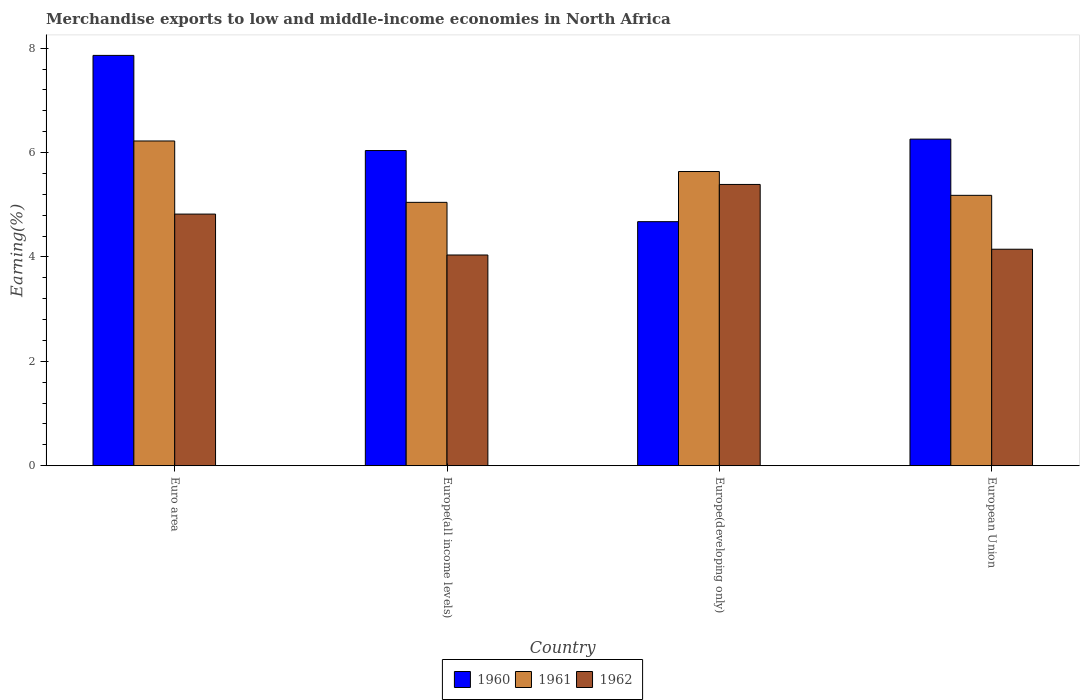How many different coloured bars are there?
Give a very brief answer. 3. How many groups of bars are there?
Give a very brief answer. 4. How many bars are there on the 2nd tick from the left?
Your response must be concise. 3. How many bars are there on the 4th tick from the right?
Your answer should be very brief. 3. What is the label of the 1st group of bars from the left?
Your answer should be compact. Euro area. In how many cases, is the number of bars for a given country not equal to the number of legend labels?
Ensure brevity in your answer.  0. What is the percentage of amount earned from merchandise exports in 1961 in Euro area?
Your response must be concise. 6.22. Across all countries, what is the maximum percentage of amount earned from merchandise exports in 1962?
Ensure brevity in your answer.  5.39. Across all countries, what is the minimum percentage of amount earned from merchandise exports in 1962?
Provide a succinct answer. 4.04. In which country was the percentage of amount earned from merchandise exports in 1960 maximum?
Provide a succinct answer. Euro area. In which country was the percentage of amount earned from merchandise exports in 1960 minimum?
Provide a succinct answer. Europe(developing only). What is the total percentage of amount earned from merchandise exports in 1962 in the graph?
Provide a succinct answer. 18.4. What is the difference between the percentage of amount earned from merchandise exports in 1960 in Euro area and that in Europe(all income levels)?
Offer a terse response. 1.82. What is the difference between the percentage of amount earned from merchandise exports in 1960 in Europe(developing only) and the percentage of amount earned from merchandise exports in 1962 in Europe(all income levels)?
Keep it short and to the point. 0.64. What is the average percentage of amount earned from merchandise exports in 1960 per country?
Provide a short and direct response. 6.21. What is the difference between the percentage of amount earned from merchandise exports of/in 1962 and percentage of amount earned from merchandise exports of/in 1960 in Europe(developing only)?
Ensure brevity in your answer.  0.71. In how many countries, is the percentage of amount earned from merchandise exports in 1961 greater than 4.4 %?
Offer a terse response. 4. What is the ratio of the percentage of amount earned from merchandise exports in 1960 in Euro area to that in European Union?
Your answer should be very brief. 1.26. Is the percentage of amount earned from merchandise exports in 1960 in Europe(developing only) less than that in European Union?
Provide a succinct answer. Yes. What is the difference between the highest and the second highest percentage of amount earned from merchandise exports in 1961?
Make the answer very short. -0.46. What is the difference between the highest and the lowest percentage of amount earned from merchandise exports in 1962?
Your answer should be very brief. 1.35. Is the sum of the percentage of amount earned from merchandise exports in 1961 in Europe(all income levels) and Europe(developing only) greater than the maximum percentage of amount earned from merchandise exports in 1960 across all countries?
Ensure brevity in your answer.  Yes. What does the 3rd bar from the left in European Union represents?
Keep it short and to the point. 1962. What does the 3rd bar from the right in Europe(all income levels) represents?
Offer a very short reply. 1960. Is it the case that in every country, the sum of the percentage of amount earned from merchandise exports in 1961 and percentage of amount earned from merchandise exports in 1962 is greater than the percentage of amount earned from merchandise exports in 1960?
Offer a terse response. Yes. Are all the bars in the graph horizontal?
Your response must be concise. No. How many countries are there in the graph?
Provide a short and direct response. 4. Are the values on the major ticks of Y-axis written in scientific E-notation?
Your answer should be compact. No. Does the graph contain any zero values?
Your response must be concise. No. How are the legend labels stacked?
Your answer should be compact. Horizontal. What is the title of the graph?
Your response must be concise. Merchandise exports to low and middle-income economies in North Africa. Does "1969" appear as one of the legend labels in the graph?
Give a very brief answer. No. What is the label or title of the Y-axis?
Offer a very short reply. Earning(%). What is the Earning(%) in 1960 in Euro area?
Provide a short and direct response. 7.86. What is the Earning(%) of 1961 in Euro area?
Provide a short and direct response. 6.22. What is the Earning(%) in 1962 in Euro area?
Your answer should be very brief. 4.82. What is the Earning(%) of 1960 in Europe(all income levels)?
Provide a short and direct response. 6.04. What is the Earning(%) of 1961 in Europe(all income levels)?
Your answer should be very brief. 5.05. What is the Earning(%) in 1962 in Europe(all income levels)?
Offer a terse response. 4.04. What is the Earning(%) in 1960 in Europe(developing only)?
Your answer should be compact. 4.68. What is the Earning(%) in 1961 in Europe(developing only)?
Offer a terse response. 5.64. What is the Earning(%) in 1962 in Europe(developing only)?
Make the answer very short. 5.39. What is the Earning(%) of 1960 in European Union?
Give a very brief answer. 6.26. What is the Earning(%) of 1961 in European Union?
Keep it short and to the point. 5.18. What is the Earning(%) of 1962 in European Union?
Keep it short and to the point. 4.15. Across all countries, what is the maximum Earning(%) in 1960?
Make the answer very short. 7.86. Across all countries, what is the maximum Earning(%) of 1961?
Provide a succinct answer. 6.22. Across all countries, what is the maximum Earning(%) in 1962?
Keep it short and to the point. 5.39. Across all countries, what is the minimum Earning(%) of 1960?
Your response must be concise. 4.68. Across all countries, what is the minimum Earning(%) of 1961?
Provide a short and direct response. 5.05. Across all countries, what is the minimum Earning(%) in 1962?
Keep it short and to the point. 4.04. What is the total Earning(%) in 1960 in the graph?
Keep it short and to the point. 24.84. What is the total Earning(%) in 1961 in the graph?
Provide a succinct answer. 22.09. What is the total Earning(%) of 1962 in the graph?
Your response must be concise. 18.4. What is the difference between the Earning(%) in 1960 in Euro area and that in Europe(all income levels)?
Offer a very short reply. 1.82. What is the difference between the Earning(%) of 1961 in Euro area and that in Europe(all income levels)?
Provide a succinct answer. 1.18. What is the difference between the Earning(%) in 1962 in Euro area and that in Europe(all income levels)?
Keep it short and to the point. 0.78. What is the difference between the Earning(%) of 1960 in Euro area and that in Europe(developing only)?
Your response must be concise. 3.19. What is the difference between the Earning(%) of 1961 in Euro area and that in Europe(developing only)?
Offer a terse response. 0.59. What is the difference between the Earning(%) in 1962 in Euro area and that in Europe(developing only)?
Ensure brevity in your answer.  -0.57. What is the difference between the Earning(%) in 1960 in Euro area and that in European Union?
Offer a terse response. 1.6. What is the difference between the Earning(%) in 1961 in Euro area and that in European Union?
Make the answer very short. 1.04. What is the difference between the Earning(%) in 1962 in Euro area and that in European Union?
Make the answer very short. 0.67. What is the difference between the Earning(%) of 1960 in Europe(all income levels) and that in Europe(developing only)?
Your response must be concise. 1.36. What is the difference between the Earning(%) in 1961 in Europe(all income levels) and that in Europe(developing only)?
Your response must be concise. -0.59. What is the difference between the Earning(%) of 1962 in Europe(all income levels) and that in Europe(developing only)?
Offer a terse response. -1.35. What is the difference between the Earning(%) in 1960 in Europe(all income levels) and that in European Union?
Make the answer very short. -0.22. What is the difference between the Earning(%) of 1961 in Europe(all income levels) and that in European Union?
Give a very brief answer. -0.13. What is the difference between the Earning(%) in 1962 in Europe(all income levels) and that in European Union?
Keep it short and to the point. -0.11. What is the difference between the Earning(%) in 1960 in Europe(developing only) and that in European Union?
Make the answer very short. -1.58. What is the difference between the Earning(%) in 1961 in Europe(developing only) and that in European Union?
Keep it short and to the point. 0.46. What is the difference between the Earning(%) of 1962 in Europe(developing only) and that in European Union?
Provide a succinct answer. 1.24. What is the difference between the Earning(%) in 1960 in Euro area and the Earning(%) in 1961 in Europe(all income levels)?
Provide a succinct answer. 2.82. What is the difference between the Earning(%) of 1960 in Euro area and the Earning(%) of 1962 in Europe(all income levels)?
Make the answer very short. 3.82. What is the difference between the Earning(%) in 1961 in Euro area and the Earning(%) in 1962 in Europe(all income levels)?
Ensure brevity in your answer.  2.18. What is the difference between the Earning(%) of 1960 in Euro area and the Earning(%) of 1961 in Europe(developing only)?
Offer a terse response. 2.23. What is the difference between the Earning(%) in 1960 in Euro area and the Earning(%) in 1962 in Europe(developing only)?
Your answer should be compact. 2.47. What is the difference between the Earning(%) in 1961 in Euro area and the Earning(%) in 1962 in Europe(developing only)?
Offer a very short reply. 0.83. What is the difference between the Earning(%) in 1960 in Euro area and the Earning(%) in 1961 in European Union?
Offer a very short reply. 2.68. What is the difference between the Earning(%) in 1960 in Euro area and the Earning(%) in 1962 in European Union?
Your response must be concise. 3.71. What is the difference between the Earning(%) in 1961 in Euro area and the Earning(%) in 1962 in European Union?
Provide a succinct answer. 2.07. What is the difference between the Earning(%) in 1960 in Europe(all income levels) and the Earning(%) in 1961 in Europe(developing only)?
Offer a very short reply. 0.4. What is the difference between the Earning(%) in 1960 in Europe(all income levels) and the Earning(%) in 1962 in Europe(developing only)?
Offer a very short reply. 0.65. What is the difference between the Earning(%) of 1961 in Europe(all income levels) and the Earning(%) of 1962 in Europe(developing only)?
Give a very brief answer. -0.34. What is the difference between the Earning(%) of 1960 in Europe(all income levels) and the Earning(%) of 1961 in European Union?
Ensure brevity in your answer.  0.86. What is the difference between the Earning(%) in 1960 in Europe(all income levels) and the Earning(%) in 1962 in European Union?
Offer a very short reply. 1.89. What is the difference between the Earning(%) of 1961 in Europe(all income levels) and the Earning(%) of 1962 in European Union?
Provide a succinct answer. 0.9. What is the difference between the Earning(%) of 1960 in Europe(developing only) and the Earning(%) of 1961 in European Union?
Give a very brief answer. -0.5. What is the difference between the Earning(%) in 1960 in Europe(developing only) and the Earning(%) in 1962 in European Union?
Keep it short and to the point. 0.53. What is the difference between the Earning(%) in 1961 in Europe(developing only) and the Earning(%) in 1962 in European Union?
Your answer should be compact. 1.49. What is the average Earning(%) of 1960 per country?
Offer a very short reply. 6.21. What is the average Earning(%) in 1961 per country?
Ensure brevity in your answer.  5.52. What is the average Earning(%) in 1962 per country?
Offer a terse response. 4.6. What is the difference between the Earning(%) of 1960 and Earning(%) of 1961 in Euro area?
Your answer should be compact. 1.64. What is the difference between the Earning(%) of 1960 and Earning(%) of 1962 in Euro area?
Your answer should be very brief. 3.04. What is the difference between the Earning(%) of 1961 and Earning(%) of 1962 in Euro area?
Provide a short and direct response. 1.4. What is the difference between the Earning(%) of 1960 and Earning(%) of 1962 in Europe(all income levels)?
Give a very brief answer. 2. What is the difference between the Earning(%) in 1961 and Earning(%) in 1962 in Europe(all income levels)?
Keep it short and to the point. 1.01. What is the difference between the Earning(%) in 1960 and Earning(%) in 1961 in Europe(developing only)?
Offer a terse response. -0.96. What is the difference between the Earning(%) of 1960 and Earning(%) of 1962 in Europe(developing only)?
Make the answer very short. -0.71. What is the difference between the Earning(%) in 1961 and Earning(%) in 1962 in Europe(developing only)?
Provide a short and direct response. 0.25. What is the difference between the Earning(%) in 1960 and Earning(%) in 1961 in European Union?
Provide a succinct answer. 1.08. What is the difference between the Earning(%) in 1960 and Earning(%) in 1962 in European Union?
Your response must be concise. 2.11. What is the difference between the Earning(%) in 1961 and Earning(%) in 1962 in European Union?
Provide a succinct answer. 1.03. What is the ratio of the Earning(%) of 1960 in Euro area to that in Europe(all income levels)?
Your answer should be compact. 1.3. What is the ratio of the Earning(%) in 1961 in Euro area to that in Europe(all income levels)?
Give a very brief answer. 1.23. What is the ratio of the Earning(%) of 1962 in Euro area to that in Europe(all income levels)?
Your response must be concise. 1.19. What is the ratio of the Earning(%) in 1960 in Euro area to that in Europe(developing only)?
Your response must be concise. 1.68. What is the ratio of the Earning(%) of 1961 in Euro area to that in Europe(developing only)?
Your answer should be very brief. 1.1. What is the ratio of the Earning(%) in 1962 in Euro area to that in Europe(developing only)?
Your response must be concise. 0.89. What is the ratio of the Earning(%) of 1960 in Euro area to that in European Union?
Your answer should be compact. 1.26. What is the ratio of the Earning(%) of 1961 in Euro area to that in European Union?
Provide a succinct answer. 1.2. What is the ratio of the Earning(%) of 1962 in Euro area to that in European Union?
Offer a very short reply. 1.16. What is the ratio of the Earning(%) of 1960 in Europe(all income levels) to that in Europe(developing only)?
Your answer should be very brief. 1.29. What is the ratio of the Earning(%) of 1961 in Europe(all income levels) to that in Europe(developing only)?
Ensure brevity in your answer.  0.9. What is the ratio of the Earning(%) in 1962 in Europe(all income levels) to that in Europe(developing only)?
Your response must be concise. 0.75. What is the ratio of the Earning(%) in 1960 in Europe(all income levels) to that in European Union?
Your response must be concise. 0.96. What is the ratio of the Earning(%) in 1961 in Europe(all income levels) to that in European Union?
Keep it short and to the point. 0.97. What is the ratio of the Earning(%) of 1962 in Europe(all income levels) to that in European Union?
Give a very brief answer. 0.97. What is the ratio of the Earning(%) of 1960 in Europe(developing only) to that in European Union?
Provide a short and direct response. 0.75. What is the ratio of the Earning(%) of 1961 in Europe(developing only) to that in European Union?
Keep it short and to the point. 1.09. What is the ratio of the Earning(%) in 1962 in Europe(developing only) to that in European Union?
Give a very brief answer. 1.3. What is the difference between the highest and the second highest Earning(%) in 1960?
Make the answer very short. 1.6. What is the difference between the highest and the second highest Earning(%) in 1961?
Provide a succinct answer. 0.59. What is the difference between the highest and the second highest Earning(%) of 1962?
Your answer should be very brief. 0.57. What is the difference between the highest and the lowest Earning(%) in 1960?
Provide a short and direct response. 3.19. What is the difference between the highest and the lowest Earning(%) of 1961?
Your answer should be very brief. 1.18. What is the difference between the highest and the lowest Earning(%) of 1962?
Your response must be concise. 1.35. 